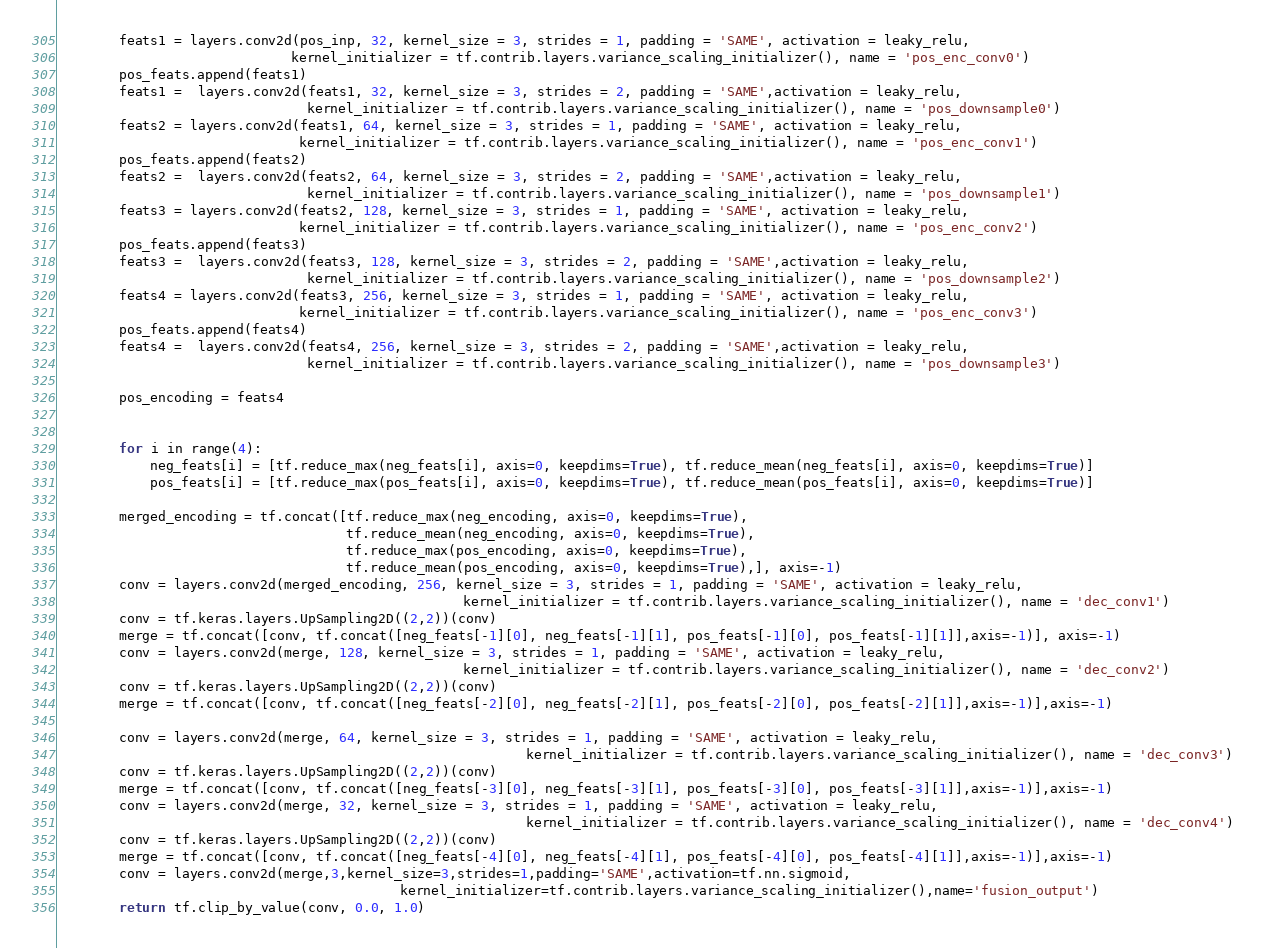<code> <loc_0><loc_0><loc_500><loc_500><_Python_>        feats1 = layers.conv2d(pos_inp, 32, kernel_size = 3, strides = 1, padding = 'SAME', activation = leaky_relu,
                              kernel_initializer = tf.contrib.layers.variance_scaling_initializer(), name = 'pos_enc_conv0')
        pos_feats.append(feats1)
        feats1 =  layers.conv2d(feats1, 32, kernel_size = 3, strides = 2, padding = 'SAME',activation = leaky_relu,
                                kernel_initializer = tf.contrib.layers.variance_scaling_initializer(), name = 'pos_downsample0')
        feats2 = layers.conv2d(feats1, 64, kernel_size = 3, strides = 1, padding = 'SAME', activation = leaky_relu,
                               kernel_initializer = tf.contrib.layers.variance_scaling_initializer(), name = 'pos_enc_conv1')
        pos_feats.append(feats2)
        feats2 =  layers.conv2d(feats2, 64, kernel_size = 3, strides = 2, padding = 'SAME',activation = leaky_relu,
                                kernel_initializer = tf.contrib.layers.variance_scaling_initializer(), name = 'pos_downsample1')
        feats3 = layers.conv2d(feats2, 128, kernel_size = 3, strides = 1, padding = 'SAME', activation = leaky_relu,
                               kernel_initializer = tf.contrib.layers.variance_scaling_initializer(), name = 'pos_enc_conv2')
        pos_feats.append(feats3)
        feats3 =  layers.conv2d(feats3, 128, kernel_size = 3, strides = 2, padding = 'SAME',activation = leaky_relu,
                                kernel_initializer = tf.contrib.layers.variance_scaling_initializer(), name = 'pos_downsample2')
        feats4 = layers.conv2d(feats3, 256, kernel_size = 3, strides = 1, padding = 'SAME', activation = leaky_relu,
                               kernel_initializer = tf.contrib.layers.variance_scaling_initializer(), name = 'pos_enc_conv3')
        pos_feats.append(feats4)
        feats4 =  layers.conv2d(feats4, 256, kernel_size = 3, strides = 2, padding = 'SAME',activation = leaky_relu,
                                kernel_initializer = tf.contrib.layers.variance_scaling_initializer(), name = 'pos_downsample3')
         
        pos_encoding = feats4


        for i in range(4):
            neg_feats[i] = [tf.reduce_max(neg_feats[i], axis=0, keepdims=True), tf.reduce_mean(neg_feats[i], axis=0, keepdims=True)]
            pos_feats[i] = [tf.reduce_max(pos_feats[i], axis=0, keepdims=True), tf.reduce_mean(pos_feats[i], axis=0, keepdims=True)]
       
        merged_encoding = tf.concat([tf.reduce_max(neg_encoding, axis=0, keepdims=True),
                                     tf.reduce_mean(neg_encoding, axis=0, keepdims=True),
                                     tf.reduce_max(pos_encoding, axis=0, keepdims=True),
                                     tf.reduce_mean(pos_encoding, axis=0, keepdims=True),], axis=-1)
        conv = layers.conv2d(merged_encoding, 256, kernel_size = 3, strides = 1, padding = 'SAME', activation = leaky_relu,
                                                    kernel_initializer = tf.contrib.layers.variance_scaling_initializer(), name = 'dec_conv1')
        conv = tf.keras.layers.UpSampling2D((2,2))(conv)
        merge = tf.concat([conv, tf.concat([neg_feats[-1][0], neg_feats[-1][1], pos_feats[-1][0], pos_feats[-1][1]],axis=-1)], axis=-1)
        conv = layers.conv2d(merge, 128, kernel_size = 3, strides = 1, padding = 'SAME', activation = leaky_relu,
                                                    kernel_initializer = tf.contrib.layers.variance_scaling_initializer(), name = 'dec_conv2')
        conv = tf.keras.layers.UpSampling2D((2,2))(conv)
        merge = tf.concat([conv, tf.concat([neg_feats[-2][0], neg_feats[-2][1], pos_feats[-2][0], pos_feats[-2][1]],axis=-1)],axis=-1)

        conv = layers.conv2d(merge, 64, kernel_size = 3, strides = 1, padding = 'SAME', activation = leaky_relu,
                                                            kernel_initializer = tf.contrib.layers.variance_scaling_initializer(), name = 'dec_conv3')
        conv = tf.keras.layers.UpSampling2D((2,2))(conv)
        merge = tf.concat([conv, tf.concat([neg_feats[-3][0], neg_feats[-3][1], pos_feats[-3][0], pos_feats[-3][1]],axis=-1)],axis=-1)
        conv = layers.conv2d(merge, 32, kernel_size = 3, strides = 1, padding = 'SAME', activation = leaky_relu,
                                                            kernel_initializer = tf.contrib.layers.variance_scaling_initializer(), name = 'dec_conv4')
        conv = tf.keras.layers.UpSampling2D((2,2))(conv)
        merge = tf.concat([conv, tf.concat([neg_feats[-4][0], neg_feats[-4][1], pos_feats[-4][0], pos_feats[-4][1]],axis=-1)],axis=-1)
        conv = layers.conv2d(merge,3,kernel_size=3,strides=1,padding='SAME',activation=tf.nn.sigmoid,
                                            kernel_initializer=tf.contrib.layers.variance_scaling_initializer(),name='fusion_output')
        return tf.clip_by_value(conv, 0.0, 1.0)

</code> 